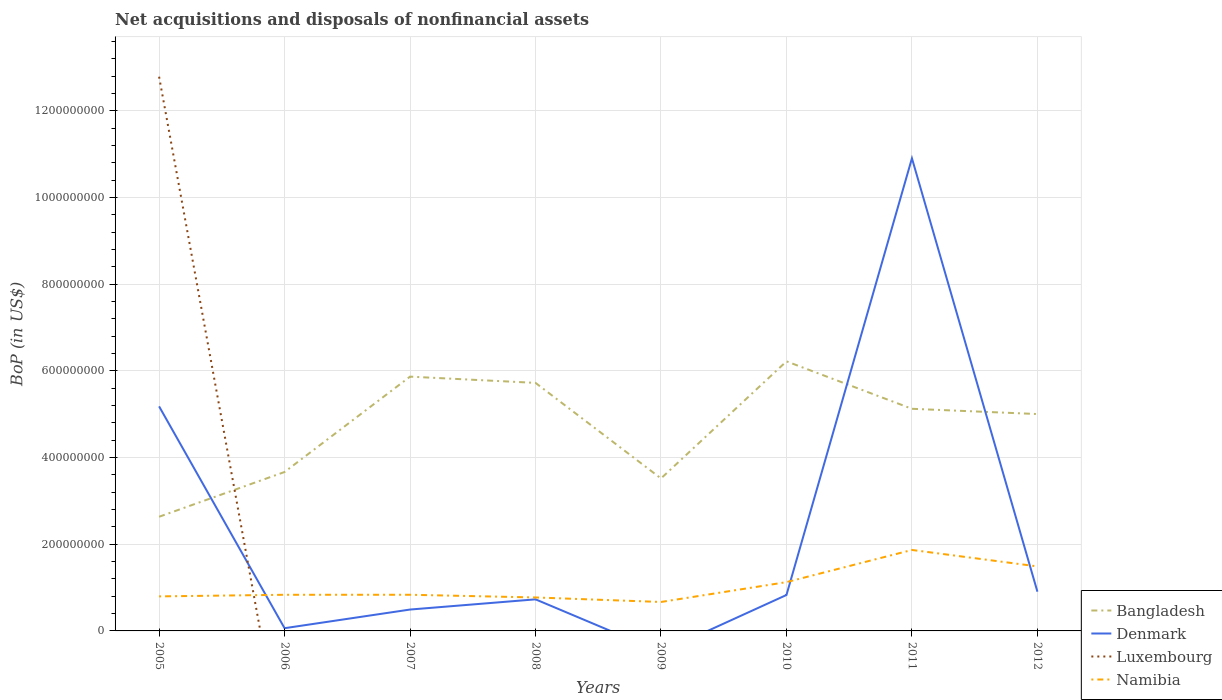Across all years, what is the maximum Balance of Payments in Denmark?
Your answer should be very brief. 0. What is the total Balance of Payments in Namibia in the graph?
Offer a very short reply. -1.10e+08. What is the difference between the highest and the second highest Balance of Payments in Bangladesh?
Your answer should be compact. 3.59e+08. How many lines are there?
Your answer should be compact. 4. How many years are there in the graph?
Your response must be concise. 8. What is the difference between two consecutive major ticks on the Y-axis?
Keep it short and to the point. 2.00e+08. Does the graph contain any zero values?
Your response must be concise. Yes. What is the title of the graph?
Make the answer very short. Net acquisitions and disposals of nonfinancial assets. What is the label or title of the X-axis?
Offer a terse response. Years. What is the label or title of the Y-axis?
Ensure brevity in your answer.  BoP (in US$). What is the BoP (in US$) of Bangladesh in 2005?
Your answer should be compact. 2.63e+08. What is the BoP (in US$) in Denmark in 2005?
Offer a very short reply. 5.18e+08. What is the BoP (in US$) of Luxembourg in 2005?
Make the answer very short. 1.28e+09. What is the BoP (in US$) of Namibia in 2005?
Keep it short and to the point. 7.97e+07. What is the BoP (in US$) in Bangladesh in 2006?
Offer a terse response. 3.67e+08. What is the BoP (in US$) in Denmark in 2006?
Provide a short and direct response. 6.28e+06. What is the BoP (in US$) in Namibia in 2006?
Ensure brevity in your answer.  8.34e+07. What is the BoP (in US$) in Bangladesh in 2007?
Make the answer very short. 5.87e+08. What is the BoP (in US$) in Denmark in 2007?
Your answer should be compact. 4.93e+07. What is the BoP (in US$) of Namibia in 2007?
Your answer should be compact. 8.34e+07. What is the BoP (in US$) of Bangladesh in 2008?
Make the answer very short. 5.72e+08. What is the BoP (in US$) in Denmark in 2008?
Ensure brevity in your answer.  7.29e+07. What is the BoP (in US$) of Luxembourg in 2008?
Ensure brevity in your answer.  0. What is the BoP (in US$) in Namibia in 2008?
Provide a succinct answer. 7.72e+07. What is the BoP (in US$) of Bangladesh in 2009?
Make the answer very short. 3.52e+08. What is the BoP (in US$) in Denmark in 2009?
Offer a very short reply. 0. What is the BoP (in US$) of Namibia in 2009?
Make the answer very short. 6.68e+07. What is the BoP (in US$) of Bangladesh in 2010?
Keep it short and to the point. 6.22e+08. What is the BoP (in US$) of Denmark in 2010?
Your response must be concise. 8.29e+07. What is the BoP (in US$) in Luxembourg in 2010?
Keep it short and to the point. 0. What is the BoP (in US$) of Namibia in 2010?
Offer a very short reply. 1.13e+08. What is the BoP (in US$) of Bangladesh in 2011?
Provide a succinct answer. 5.12e+08. What is the BoP (in US$) in Denmark in 2011?
Your answer should be very brief. 1.09e+09. What is the BoP (in US$) of Namibia in 2011?
Make the answer very short. 1.87e+08. What is the BoP (in US$) of Bangladesh in 2012?
Keep it short and to the point. 5.00e+08. What is the BoP (in US$) of Denmark in 2012?
Your response must be concise. 9.05e+07. What is the BoP (in US$) of Namibia in 2012?
Your response must be concise. 1.49e+08. Across all years, what is the maximum BoP (in US$) in Bangladesh?
Provide a succinct answer. 6.22e+08. Across all years, what is the maximum BoP (in US$) of Denmark?
Your answer should be very brief. 1.09e+09. Across all years, what is the maximum BoP (in US$) in Luxembourg?
Offer a terse response. 1.28e+09. Across all years, what is the maximum BoP (in US$) of Namibia?
Your answer should be compact. 1.87e+08. Across all years, what is the minimum BoP (in US$) of Bangladesh?
Ensure brevity in your answer.  2.63e+08. Across all years, what is the minimum BoP (in US$) of Denmark?
Your answer should be compact. 0. Across all years, what is the minimum BoP (in US$) of Luxembourg?
Ensure brevity in your answer.  0. Across all years, what is the minimum BoP (in US$) in Namibia?
Your answer should be compact. 6.68e+07. What is the total BoP (in US$) in Bangladesh in the graph?
Your answer should be compact. 3.77e+09. What is the total BoP (in US$) of Denmark in the graph?
Offer a very short reply. 1.91e+09. What is the total BoP (in US$) of Luxembourg in the graph?
Offer a very short reply. 1.28e+09. What is the total BoP (in US$) in Namibia in the graph?
Keep it short and to the point. 8.39e+08. What is the difference between the BoP (in US$) of Bangladesh in 2005 and that in 2006?
Ensure brevity in your answer.  -1.03e+08. What is the difference between the BoP (in US$) of Denmark in 2005 and that in 2006?
Your answer should be compact. 5.12e+08. What is the difference between the BoP (in US$) in Namibia in 2005 and that in 2006?
Provide a succinct answer. -3.73e+06. What is the difference between the BoP (in US$) in Bangladesh in 2005 and that in 2007?
Your response must be concise. -3.23e+08. What is the difference between the BoP (in US$) in Denmark in 2005 and that in 2007?
Offer a very short reply. 4.69e+08. What is the difference between the BoP (in US$) of Namibia in 2005 and that in 2007?
Your response must be concise. -3.75e+06. What is the difference between the BoP (in US$) of Bangladesh in 2005 and that in 2008?
Ensure brevity in your answer.  -3.09e+08. What is the difference between the BoP (in US$) of Denmark in 2005 and that in 2008?
Ensure brevity in your answer.  4.45e+08. What is the difference between the BoP (in US$) in Namibia in 2005 and that in 2008?
Keep it short and to the point. 2.45e+06. What is the difference between the BoP (in US$) in Bangladesh in 2005 and that in 2009?
Give a very brief answer. -8.84e+07. What is the difference between the BoP (in US$) of Namibia in 2005 and that in 2009?
Provide a succinct answer. 1.29e+07. What is the difference between the BoP (in US$) in Bangladesh in 2005 and that in 2010?
Provide a succinct answer. -3.59e+08. What is the difference between the BoP (in US$) in Denmark in 2005 and that in 2010?
Keep it short and to the point. 4.35e+08. What is the difference between the BoP (in US$) of Namibia in 2005 and that in 2010?
Offer a terse response. -3.29e+07. What is the difference between the BoP (in US$) of Bangladesh in 2005 and that in 2011?
Your response must be concise. -2.49e+08. What is the difference between the BoP (in US$) of Denmark in 2005 and that in 2011?
Provide a succinct answer. -5.72e+08. What is the difference between the BoP (in US$) of Namibia in 2005 and that in 2011?
Offer a terse response. -1.07e+08. What is the difference between the BoP (in US$) of Bangladesh in 2005 and that in 2012?
Make the answer very short. -2.37e+08. What is the difference between the BoP (in US$) in Denmark in 2005 and that in 2012?
Provide a short and direct response. 4.27e+08. What is the difference between the BoP (in US$) of Namibia in 2005 and that in 2012?
Provide a short and direct response. -6.92e+07. What is the difference between the BoP (in US$) in Bangladesh in 2006 and that in 2007?
Your answer should be very brief. -2.20e+08. What is the difference between the BoP (in US$) of Denmark in 2006 and that in 2007?
Your answer should be compact. -4.30e+07. What is the difference between the BoP (in US$) of Namibia in 2006 and that in 2007?
Your response must be concise. -2.69e+04. What is the difference between the BoP (in US$) of Bangladesh in 2006 and that in 2008?
Offer a very short reply. -2.06e+08. What is the difference between the BoP (in US$) of Denmark in 2006 and that in 2008?
Ensure brevity in your answer.  -6.66e+07. What is the difference between the BoP (in US$) in Namibia in 2006 and that in 2008?
Your answer should be very brief. 6.18e+06. What is the difference between the BoP (in US$) of Bangladesh in 2006 and that in 2009?
Give a very brief answer. 1.48e+07. What is the difference between the BoP (in US$) of Namibia in 2006 and that in 2009?
Offer a terse response. 1.66e+07. What is the difference between the BoP (in US$) of Bangladesh in 2006 and that in 2010?
Give a very brief answer. -2.55e+08. What is the difference between the BoP (in US$) of Denmark in 2006 and that in 2010?
Offer a very short reply. -7.66e+07. What is the difference between the BoP (in US$) of Namibia in 2006 and that in 2010?
Keep it short and to the point. -2.92e+07. What is the difference between the BoP (in US$) in Bangladesh in 2006 and that in 2011?
Make the answer very short. -1.46e+08. What is the difference between the BoP (in US$) in Denmark in 2006 and that in 2011?
Keep it short and to the point. -1.08e+09. What is the difference between the BoP (in US$) in Namibia in 2006 and that in 2011?
Offer a terse response. -1.03e+08. What is the difference between the BoP (in US$) in Bangladesh in 2006 and that in 2012?
Provide a succinct answer. -1.34e+08. What is the difference between the BoP (in US$) in Denmark in 2006 and that in 2012?
Keep it short and to the point. -8.43e+07. What is the difference between the BoP (in US$) in Namibia in 2006 and that in 2012?
Offer a terse response. -6.54e+07. What is the difference between the BoP (in US$) of Bangladesh in 2007 and that in 2008?
Give a very brief answer. 1.44e+07. What is the difference between the BoP (in US$) in Denmark in 2007 and that in 2008?
Ensure brevity in your answer.  -2.35e+07. What is the difference between the BoP (in US$) in Namibia in 2007 and that in 2008?
Offer a very short reply. 6.20e+06. What is the difference between the BoP (in US$) in Bangladesh in 2007 and that in 2009?
Provide a succinct answer. 2.35e+08. What is the difference between the BoP (in US$) of Namibia in 2007 and that in 2009?
Ensure brevity in your answer.  1.66e+07. What is the difference between the BoP (in US$) in Bangladesh in 2007 and that in 2010?
Your answer should be compact. -3.53e+07. What is the difference between the BoP (in US$) in Denmark in 2007 and that in 2010?
Ensure brevity in your answer.  -3.36e+07. What is the difference between the BoP (in US$) of Namibia in 2007 and that in 2010?
Keep it short and to the point. -2.92e+07. What is the difference between the BoP (in US$) in Bangladesh in 2007 and that in 2011?
Ensure brevity in your answer.  7.41e+07. What is the difference between the BoP (in US$) of Denmark in 2007 and that in 2011?
Your answer should be compact. -1.04e+09. What is the difference between the BoP (in US$) in Namibia in 2007 and that in 2011?
Keep it short and to the point. -1.03e+08. What is the difference between the BoP (in US$) in Bangladesh in 2007 and that in 2012?
Your answer should be compact. 8.63e+07. What is the difference between the BoP (in US$) of Denmark in 2007 and that in 2012?
Your response must be concise. -4.12e+07. What is the difference between the BoP (in US$) in Namibia in 2007 and that in 2012?
Your response must be concise. -6.54e+07. What is the difference between the BoP (in US$) of Bangladesh in 2008 and that in 2009?
Provide a succinct answer. 2.20e+08. What is the difference between the BoP (in US$) in Namibia in 2008 and that in 2009?
Provide a short and direct response. 1.04e+07. What is the difference between the BoP (in US$) in Bangladesh in 2008 and that in 2010?
Keep it short and to the point. -4.97e+07. What is the difference between the BoP (in US$) in Denmark in 2008 and that in 2010?
Your answer should be compact. -1.00e+07. What is the difference between the BoP (in US$) of Namibia in 2008 and that in 2010?
Provide a succinct answer. -3.54e+07. What is the difference between the BoP (in US$) in Bangladesh in 2008 and that in 2011?
Give a very brief answer. 5.98e+07. What is the difference between the BoP (in US$) of Denmark in 2008 and that in 2011?
Ensure brevity in your answer.  -1.02e+09. What is the difference between the BoP (in US$) in Namibia in 2008 and that in 2011?
Offer a very short reply. -1.10e+08. What is the difference between the BoP (in US$) of Bangladesh in 2008 and that in 2012?
Ensure brevity in your answer.  7.19e+07. What is the difference between the BoP (in US$) in Denmark in 2008 and that in 2012?
Provide a short and direct response. -1.77e+07. What is the difference between the BoP (in US$) in Namibia in 2008 and that in 2012?
Offer a terse response. -7.16e+07. What is the difference between the BoP (in US$) of Bangladesh in 2009 and that in 2010?
Give a very brief answer. -2.70e+08. What is the difference between the BoP (in US$) in Namibia in 2009 and that in 2010?
Offer a terse response. -4.58e+07. What is the difference between the BoP (in US$) of Bangladesh in 2009 and that in 2011?
Give a very brief answer. -1.61e+08. What is the difference between the BoP (in US$) of Namibia in 2009 and that in 2011?
Ensure brevity in your answer.  -1.20e+08. What is the difference between the BoP (in US$) in Bangladesh in 2009 and that in 2012?
Make the answer very short. -1.48e+08. What is the difference between the BoP (in US$) of Namibia in 2009 and that in 2012?
Make the answer very short. -8.21e+07. What is the difference between the BoP (in US$) of Bangladesh in 2010 and that in 2011?
Your response must be concise. 1.09e+08. What is the difference between the BoP (in US$) in Denmark in 2010 and that in 2011?
Offer a terse response. -1.01e+09. What is the difference between the BoP (in US$) of Namibia in 2010 and that in 2011?
Your response must be concise. -7.42e+07. What is the difference between the BoP (in US$) of Bangladesh in 2010 and that in 2012?
Provide a short and direct response. 1.22e+08. What is the difference between the BoP (in US$) of Denmark in 2010 and that in 2012?
Offer a very short reply. -7.67e+06. What is the difference between the BoP (in US$) of Namibia in 2010 and that in 2012?
Your answer should be very brief. -3.63e+07. What is the difference between the BoP (in US$) of Bangladesh in 2011 and that in 2012?
Offer a very short reply. 1.21e+07. What is the difference between the BoP (in US$) in Denmark in 2011 and that in 2012?
Ensure brevity in your answer.  1.00e+09. What is the difference between the BoP (in US$) of Namibia in 2011 and that in 2012?
Offer a very short reply. 3.79e+07. What is the difference between the BoP (in US$) of Bangladesh in 2005 and the BoP (in US$) of Denmark in 2006?
Give a very brief answer. 2.57e+08. What is the difference between the BoP (in US$) in Bangladesh in 2005 and the BoP (in US$) in Namibia in 2006?
Offer a terse response. 1.80e+08. What is the difference between the BoP (in US$) in Denmark in 2005 and the BoP (in US$) in Namibia in 2006?
Offer a terse response. 4.35e+08. What is the difference between the BoP (in US$) in Luxembourg in 2005 and the BoP (in US$) in Namibia in 2006?
Your answer should be very brief. 1.20e+09. What is the difference between the BoP (in US$) in Bangladesh in 2005 and the BoP (in US$) in Denmark in 2007?
Your answer should be compact. 2.14e+08. What is the difference between the BoP (in US$) in Bangladesh in 2005 and the BoP (in US$) in Namibia in 2007?
Your response must be concise. 1.80e+08. What is the difference between the BoP (in US$) in Denmark in 2005 and the BoP (in US$) in Namibia in 2007?
Your answer should be very brief. 4.35e+08. What is the difference between the BoP (in US$) of Luxembourg in 2005 and the BoP (in US$) of Namibia in 2007?
Your answer should be very brief. 1.20e+09. What is the difference between the BoP (in US$) of Bangladesh in 2005 and the BoP (in US$) of Denmark in 2008?
Your response must be concise. 1.90e+08. What is the difference between the BoP (in US$) in Bangladesh in 2005 and the BoP (in US$) in Namibia in 2008?
Keep it short and to the point. 1.86e+08. What is the difference between the BoP (in US$) of Denmark in 2005 and the BoP (in US$) of Namibia in 2008?
Provide a short and direct response. 4.41e+08. What is the difference between the BoP (in US$) in Luxembourg in 2005 and the BoP (in US$) in Namibia in 2008?
Give a very brief answer. 1.20e+09. What is the difference between the BoP (in US$) in Bangladesh in 2005 and the BoP (in US$) in Namibia in 2009?
Offer a terse response. 1.97e+08. What is the difference between the BoP (in US$) of Denmark in 2005 and the BoP (in US$) of Namibia in 2009?
Your answer should be compact. 4.51e+08. What is the difference between the BoP (in US$) of Luxembourg in 2005 and the BoP (in US$) of Namibia in 2009?
Offer a terse response. 1.21e+09. What is the difference between the BoP (in US$) in Bangladesh in 2005 and the BoP (in US$) in Denmark in 2010?
Your answer should be compact. 1.80e+08. What is the difference between the BoP (in US$) in Bangladesh in 2005 and the BoP (in US$) in Namibia in 2010?
Give a very brief answer. 1.51e+08. What is the difference between the BoP (in US$) of Denmark in 2005 and the BoP (in US$) of Namibia in 2010?
Make the answer very short. 4.05e+08. What is the difference between the BoP (in US$) in Luxembourg in 2005 and the BoP (in US$) in Namibia in 2010?
Make the answer very short. 1.17e+09. What is the difference between the BoP (in US$) in Bangladesh in 2005 and the BoP (in US$) in Denmark in 2011?
Make the answer very short. -8.27e+08. What is the difference between the BoP (in US$) of Bangladesh in 2005 and the BoP (in US$) of Namibia in 2011?
Offer a very short reply. 7.66e+07. What is the difference between the BoP (in US$) of Denmark in 2005 and the BoP (in US$) of Namibia in 2011?
Your answer should be very brief. 3.31e+08. What is the difference between the BoP (in US$) in Luxembourg in 2005 and the BoP (in US$) in Namibia in 2011?
Your response must be concise. 1.09e+09. What is the difference between the BoP (in US$) in Bangladesh in 2005 and the BoP (in US$) in Denmark in 2012?
Offer a very short reply. 1.73e+08. What is the difference between the BoP (in US$) in Bangladesh in 2005 and the BoP (in US$) in Namibia in 2012?
Your answer should be very brief. 1.15e+08. What is the difference between the BoP (in US$) of Denmark in 2005 and the BoP (in US$) of Namibia in 2012?
Provide a succinct answer. 3.69e+08. What is the difference between the BoP (in US$) of Luxembourg in 2005 and the BoP (in US$) of Namibia in 2012?
Your answer should be compact. 1.13e+09. What is the difference between the BoP (in US$) of Bangladesh in 2006 and the BoP (in US$) of Denmark in 2007?
Provide a short and direct response. 3.17e+08. What is the difference between the BoP (in US$) in Bangladesh in 2006 and the BoP (in US$) in Namibia in 2007?
Offer a terse response. 2.83e+08. What is the difference between the BoP (in US$) in Denmark in 2006 and the BoP (in US$) in Namibia in 2007?
Give a very brief answer. -7.71e+07. What is the difference between the BoP (in US$) of Bangladesh in 2006 and the BoP (in US$) of Denmark in 2008?
Provide a succinct answer. 2.94e+08. What is the difference between the BoP (in US$) of Bangladesh in 2006 and the BoP (in US$) of Namibia in 2008?
Your response must be concise. 2.89e+08. What is the difference between the BoP (in US$) in Denmark in 2006 and the BoP (in US$) in Namibia in 2008?
Keep it short and to the point. -7.09e+07. What is the difference between the BoP (in US$) in Bangladesh in 2006 and the BoP (in US$) in Namibia in 2009?
Your answer should be compact. 3.00e+08. What is the difference between the BoP (in US$) in Denmark in 2006 and the BoP (in US$) in Namibia in 2009?
Ensure brevity in your answer.  -6.05e+07. What is the difference between the BoP (in US$) in Bangladesh in 2006 and the BoP (in US$) in Denmark in 2010?
Provide a short and direct response. 2.84e+08. What is the difference between the BoP (in US$) in Bangladesh in 2006 and the BoP (in US$) in Namibia in 2010?
Keep it short and to the point. 2.54e+08. What is the difference between the BoP (in US$) of Denmark in 2006 and the BoP (in US$) of Namibia in 2010?
Your answer should be very brief. -1.06e+08. What is the difference between the BoP (in US$) of Bangladesh in 2006 and the BoP (in US$) of Denmark in 2011?
Ensure brevity in your answer.  -7.24e+08. What is the difference between the BoP (in US$) of Bangladesh in 2006 and the BoP (in US$) of Namibia in 2011?
Keep it short and to the point. 1.80e+08. What is the difference between the BoP (in US$) of Denmark in 2006 and the BoP (in US$) of Namibia in 2011?
Give a very brief answer. -1.80e+08. What is the difference between the BoP (in US$) of Bangladesh in 2006 and the BoP (in US$) of Denmark in 2012?
Your answer should be compact. 2.76e+08. What is the difference between the BoP (in US$) in Bangladesh in 2006 and the BoP (in US$) in Namibia in 2012?
Provide a succinct answer. 2.18e+08. What is the difference between the BoP (in US$) in Denmark in 2006 and the BoP (in US$) in Namibia in 2012?
Your response must be concise. -1.43e+08. What is the difference between the BoP (in US$) of Bangladesh in 2007 and the BoP (in US$) of Denmark in 2008?
Offer a very short reply. 5.14e+08. What is the difference between the BoP (in US$) of Bangladesh in 2007 and the BoP (in US$) of Namibia in 2008?
Provide a short and direct response. 5.09e+08. What is the difference between the BoP (in US$) in Denmark in 2007 and the BoP (in US$) in Namibia in 2008?
Ensure brevity in your answer.  -2.79e+07. What is the difference between the BoP (in US$) of Bangladesh in 2007 and the BoP (in US$) of Namibia in 2009?
Your response must be concise. 5.20e+08. What is the difference between the BoP (in US$) of Denmark in 2007 and the BoP (in US$) of Namibia in 2009?
Make the answer very short. -1.75e+07. What is the difference between the BoP (in US$) of Bangladesh in 2007 and the BoP (in US$) of Denmark in 2010?
Ensure brevity in your answer.  5.04e+08. What is the difference between the BoP (in US$) in Bangladesh in 2007 and the BoP (in US$) in Namibia in 2010?
Your answer should be compact. 4.74e+08. What is the difference between the BoP (in US$) in Denmark in 2007 and the BoP (in US$) in Namibia in 2010?
Ensure brevity in your answer.  -6.33e+07. What is the difference between the BoP (in US$) of Bangladesh in 2007 and the BoP (in US$) of Denmark in 2011?
Your answer should be compact. -5.04e+08. What is the difference between the BoP (in US$) in Bangladesh in 2007 and the BoP (in US$) in Namibia in 2011?
Offer a terse response. 4.00e+08. What is the difference between the BoP (in US$) of Denmark in 2007 and the BoP (in US$) of Namibia in 2011?
Make the answer very short. -1.37e+08. What is the difference between the BoP (in US$) of Bangladesh in 2007 and the BoP (in US$) of Denmark in 2012?
Your response must be concise. 4.96e+08. What is the difference between the BoP (in US$) in Bangladesh in 2007 and the BoP (in US$) in Namibia in 2012?
Make the answer very short. 4.38e+08. What is the difference between the BoP (in US$) in Denmark in 2007 and the BoP (in US$) in Namibia in 2012?
Your answer should be compact. -9.95e+07. What is the difference between the BoP (in US$) in Bangladesh in 2008 and the BoP (in US$) in Namibia in 2009?
Provide a succinct answer. 5.05e+08. What is the difference between the BoP (in US$) of Denmark in 2008 and the BoP (in US$) of Namibia in 2009?
Offer a terse response. 6.08e+06. What is the difference between the BoP (in US$) in Bangladesh in 2008 and the BoP (in US$) in Denmark in 2010?
Give a very brief answer. 4.89e+08. What is the difference between the BoP (in US$) of Bangladesh in 2008 and the BoP (in US$) of Namibia in 2010?
Give a very brief answer. 4.60e+08. What is the difference between the BoP (in US$) in Denmark in 2008 and the BoP (in US$) in Namibia in 2010?
Make the answer very short. -3.97e+07. What is the difference between the BoP (in US$) of Bangladesh in 2008 and the BoP (in US$) of Denmark in 2011?
Your answer should be very brief. -5.18e+08. What is the difference between the BoP (in US$) of Bangladesh in 2008 and the BoP (in US$) of Namibia in 2011?
Offer a terse response. 3.85e+08. What is the difference between the BoP (in US$) in Denmark in 2008 and the BoP (in US$) in Namibia in 2011?
Provide a succinct answer. -1.14e+08. What is the difference between the BoP (in US$) of Bangladesh in 2008 and the BoP (in US$) of Denmark in 2012?
Your answer should be compact. 4.82e+08. What is the difference between the BoP (in US$) of Bangladesh in 2008 and the BoP (in US$) of Namibia in 2012?
Your response must be concise. 4.23e+08. What is the difference between the BoP (in US$) of Denmark in 2008 and the BoP (in US$) of Namibia in 2012?
Ensure brevity in your answer.  -7.60e+07. What is the difference between the BoP (in US$) in Bangladesh in 2009 and the BoP (in US$) in Denmark in 2010?
Your answer should be compact. 2.69e+08. What is the difference between the BoP (in US$) of Bangladesh in 2009 and the BoP (in US$) of Namibia in 2010?
Your response must be concise. 2.39e+08. What is the difference between the BoP (in US$) in Bangladesh in 2009 and the BoP (in US$) in Denmark in 2011?
Make the answer very short. -7.39e+08. What is the difference between the BoP (in US$) in Bangladesh in 2009 and the BoP (in US$) in Namibia in 2011?
Ensure brevity in your answer.  1.65e+08. What is the difference between the BoP (in US$) in Bangladesh in 2009 and the BoP (in US$) in Denmark in 2012?
Ensure brevity in your answer.  2.61e+08. What is the difference between the BoP (in US$) of Bangladesh in 2009 and the BoP (in US$) of Namibia in 2012?
Keep it short and to the point. 2.03e+08. What is the difference between the BoP (in US$) of Bangladesh in 2010 and the BoP (in US$) of Denmark in 2011?
Your answer should be very brief. -4.68e+08. What is the difference between the BoP (in US$) in Bangladesh in 2010 and the BoP (in US$) in Namibia in 2011?
Your answer should be very brief. 4.35e+08. What is the difference between the BoP (in US$) of Denmark in 2010 and the BoP (in US$) of Namibia in 2011?
Provide a succinct answer. -1.04e+08. What is the difference between the BoP (in US$) in Bangladesh in 2010 and the BoP (in US$) in Denmark in 2012?
Make the answer very short. 5.31e+08. What is the difference between the BoP (in US$) in Bangladesh in 2010 and the BoP (in US$) in Namibia in 2012?
Keep it short and to the point. 4.73e+08. What is the difference between the BoP (in US$) of Denmark in 2010 and the BoP (in US$) of Namibia in 2012?
Give a very brief answer. -6.60e+07. What is the difference between the BoP (in US$) of Bangladesh in 2011 and the BoP (in US$) of Denmark in 2012?
Your answer should be very brief. 4.22e+08. What is the difference between the BoP (in US$) in Bangladesh in 2011 and the BoP (in US$) in Namibia in 2012?
Offer a very short reply. 3.64e+08. What is the difference between the BoP (in US$) of Denmark in 2011 and the BoP (in US$) of Namibia in 2012?
Your answer should be very brief. 9.41e+08. What is the average BoP (in US$) in Bangladesh per year?
Offer a terse response. 4.72e+08. What is the average BoP (in US$) in Denmark per year?
Provide a succinct answer. 2.39e+08. What is the average BoP (in US$) of Luxembourg per year?
Your answer should be compact. 1.60e+08. What is the average BoP (in US$) of Namibia per year?
Ensure brevity in your answer.  1.05e+08. In the year 2005, what is the difference between the BoP (in US$) of Bangladesh and BoP (in US$) of Denmark?
Offer a terse response. -2.55e+08. In the year 2005, what is the difference between the BoP (in US$) of Bangladesh and BoP (in US$) of Luxembourg?
Offer a terse response. -1.02e+09. In the year 2005, what is the difference between the BoP (in US$) of Bangladesh and BoP (in US$) of Namibia?
Provide a succinct answer. 1.84e+08. In the year 2005, what is the difference between the BoP (in US$) in Denmark and BoP (in US$) in Luxembourg?
Offer a very short reply. -7.60e+08. In the year 2005, what is the difference between the BoP (in US$) in Denmark and BoP (in US$) in Namibia?
Your answer should be compact. 4.38e+08. In the year 2005, what is the difference between the BoP (in US$) in Luxembourg and BoP (in US$) in Namibia?
Provide a short and direct response. 1.20e+09. In the year 2006, what is the difference between the BoP (in US$) in Bangladesh and BoP (in US$) in Denmark?
Keep it short and to the point. 3.60e+08. In the year 2006, what is the difference between the BoP (in US$) of Bangladesh and BoP (in US$) of Namibia?
Give a very brief answer. 2.83e+08. In the year 2006, what is the difference between the BoP (in US$) of Denmark and BoP (in US$) of Namibia?
Ensure brevity in your answer.  -7.71e+07. In the year 2007, what is the difference between the BoP (in US$) of Bangladesh and BoP (in US$) of Denmark?
Offer a terse response. 5.37e+08. In the year 2007, what is the difference between the BoP (in US$) of Bangladesh and BoP (in US$) of Namibia?
Your answer should be very brief. 5.03e+08. In the year 2007, what is the difference between the BoP (in US$) of Denmark and BoP (in US$) of Namibia?
Provide a short and direct response. -3.41e+07. In the year 2008, what is the difference between the BoP (in US$) in Bangladesh and BoP (in US$) in Denmark?
Your answer should be very brief. 4.99e+08. In the year 2008, what is the difference between the BoP (in US$) in Bangladesh and BoP (in US$) in Namibia?
Keep it short and to the point. 4.95e+08. In the year 2008, what is the difference between the BoP (in US$) in Denmark and BoP (in US$) in Namibia?
Provide a succinct answer. -4.35e+06. In the year 2009, what is the difference between the BoP (in US$) of Bangladesh and BoP (in US$) of Namibia?
Your answer should be very brief. 2.85e+08. In the year 2010, what is the difference between the BoP (in US$) in Bangladesh and BoP (in US$) in Denmark?
Your answer should be compact. 5.39e+08. In the year 2010, what is the difference between the BoP (in US$) in Bangladesh and BoP (in US$) in Namibia?
Your answer should be very brief. 5.09e+08. In the year 2010, what is the difference between the BoP (in US$) of Denmark and BoP (in US$) of Namibia?
Your answer should be compact. -2.97e+07. In the year 2011, what is the difference between the BoP (in US$) in Bangladesh and BoP (in US$) in Denmark?
Provide a succinct answer. -5.78e+08. In the year 2011, what is the difference between the BoP (in US$) of Bangladesh and BoP (in US$) of Namibia?
Keep it short and to the point. 3.26e+08. In the year 2011, what is the difference between the BoP (in US$) of Denmark and BoP (in US$) of Namibia?
Provide a succinct answer. 9.04e+08. In the year 2012, what is the difference between the BoP (in US$) in Bangladesh and BoP (in US$) in Denmark?
Provide a short and direct response. 4.10e+08. In the year 2012, what is the difference between the BoP (in US$) in Bangladesh and BoP (in US$) in Namibia?
Your response must be concise. 3.51e+08. In the year 2012, what is the difference between the BoP (in US$) of Denmark and BoP (in US$) of Namibia?
Your answer should be compact. -5.83e+07. What is the ratio of the BoP (in US$) of Bangladesh in 2005 to that in 2006?
Offer a very short reply. 0.72. What is the ratio of the BoP (in US$) in Denmark in 2005 to that in 2006?
Your answer should be very brief. 82.45. What is the ratio of the BoP (in US$) in Namibia in 2005 to that in 2006?
Your answer should be compact. 0.96. What is the ratio of the BoP (in US$) of Bangladesh in 2005 to that in 2007?
Offer a very short reply. 0.45. What is the ratio of the BoP (in US$) of Denmark in 2005 to that in 2007?
Ensure brevity in your answer.  10.5. What is the ratio of the BoP (in US$) in Namibia in 2005 to that in 2007?
Provide a short and direct response. 0.95. What is the ratio of the BoP (in US$) in Bangladesh in 2005 to that in 2008?
Give a very brief answer. 0.46. What is the ratio of the BoP (in US$) of Denmark in 2005 to that in 2008?
Keep it short and to the point. 7.11. What is the ratio of the BoP (in US$) of Namibia in 2005 to that in 2008?
Make the answer very short. 1.03. What is the ratio of the BoP (in US$) in Bangladesh in 2005 to that in 2009?
Your answer should be very brief. 0.75. What is the ratio of the BoP (in US$) in Namibia in 2005 to that in 2009?
Keep it short and to the point. 1.19. What is the ratio of the BoP (in US$) of Bangladesh in 2005 to that in 2010?
Your response must be concise. 0.42. What is the ratio of the BoP (in US$) of Denmark in 2005 to that in 2010?
Offer a terse response. 6.25. What is the ratio of the BoP (in US$) of Namibia in 2005 to that in 2010?
Keep it short and to the point. 0.71. What is the ratio of the BoP (in US$) in Bangladesh in 2005 to that in 2011?
Offer a terse response. 0.51. What is the ratio of the BoP (in US$) of Denmark in 2005 to that in 2011?
Your response must be concise. 0.48. What is the ratio of the BoP (in US$) in Namibia in 2005 to that in 2011?
Your answer should be compact. 0.43. What is the ratio of the BoP (in US$) in Bangladesh in 2005 to that in 2012?
Provide a short and direct response. 0.53. What is the ratio of the BoP (in US$) of Denmark in 2005 to that in 2012?
Your answer should be very brief. 5.72. What is the ratio of the BoP (in US$) in Namibia in 2005 to that in 2012?
Offer a terse response. 0.54. What is the ratio of the BoP (in US$) of Bangladesh in 2006 to that in 2007?
Ensure brevity in your answer.  0.62. What is the ratio of the BoP (in US$) in Denmark in 2006 to that in 2007?
Your answer should be compact. 0.13. What is the ratio of the BoP (in US$) of Namibia in 2006 to that in 2007?
Provide a succinct answer. 1. What is the ratio of the BoP (in US$) in Bangladesh in 2006 to that in 2008?
Provide a succinct answer. 0.64. What is the ratio of the BoP (in US$) of Denmark in 2006 to that in 2008?
Offer a terse response. 0.09. What is the ratio of the BoP (in US$) of Bangladesh in 2006 to that in 2009?
Offer a terse response. 1.04. What is the ratio of the BoP (in US$) of Namibia in 2006 to that in 2009?
Give a very brief answer. 1.25. What is the ratio of the BoP (in US$) in Bangladesh in 2006 to that in 2010?
Make the answer very short. 0.59. What is the ratio of the BoP (in US$) in Denmark in 2006 to that in 2010?
Provide a short and direct response. 0.08. What is the ratio of the BoP (in US$) of Namibia in 2006 to that in 2010?
Provide a short and direct response. 0.74. What is the ratio of the BoP (in US$) in Bangladesh in 2006 to that in 2011?
Ensure brevity in your answer.  0.72. What is the ratio of the BoP (in US$) of Denmark in 2006 to that in 2011?
Offer a terse response. 0.01. What is the ratio of the BoP (in US$) of Namibia in 2006 to that in 2011?
Offer a very short reply. 0.45. What is the ratio of the BoP (in US$) in Bangladesh in 2006 to that in 2012?
Your answer should be compact. 0.73. What is the ratio of the BoP (in US$) of Denmark in 2006 to that in 2012?
Ensure brevity in your answer.  0.07. What is the ratio of the BoP (in US$) of Namibia in 2006 to that in 2012?
Your answer should be compact. 0.56. What is the ratio of the BoP (in US$) in Bangladesh in 2007 to that in 2008?
Give a very brief answer. 1.03. What is the ratio of the BoP (in US$) in Denmark in 2007 to that in 2008?
Keep it short and to the point. 0.68. What is the ratio of the BoP (in US$) of Namibia in 2007 to that in 2008?
Make the answer very short. 1.08. What is the ratio of the BoP (in US$) of Bangladesh in 2007 to that in 2009?
Offer a terse response. 1.67. What is the ratio of the BoP (in US$) of Namibia in 2007 to that in 2009?
Ensure brevity in your answer.  1.25. What is the ratio of the BoP (in US$) of Bangladesh in 2007 to that in 2010?
Offer a terse response. 0.94. What is the ratio of the BoP (in US$) of Denmark in 2007 to that in 2010?
Provide a succinct answer. 0.59. What is the ratio of the BoP (in US$) of Namibia in 2007 to that in 2010?
Provide a succinct answer. 0.74. What is the ratio of the BoP (in US$) of Bangladesh in 2007 to that in 2011?
Your answer should be very brief. 1.14. What is the ratio of the BoP (in US$) of Denmark in 2007 to that in 2011?
Make the answer very short. 0.05. What is the ratio of the BoP (in US$) in Namibia in 2007 to that in 2011?
Give a very brief answer. 0.45. What is the ratio of the BoP (in US$) in Bangladesh in 2007 to that in 2012?
Provide a succinct answer. 1.17. What is the ratio of the BoP (in US$) of Denmark in 2007 to that in 2012?
Offer a terse response. 0.54. What is the ratio of the BoP (in US$) in Namibia in 2007 to that in 2012?
Your response must be concise. 0.56. What is the ratio of the BoP (in US$) of Bangladesh in 2008 to that in 2009?
Give a very brief answer. 1.63. What is the ratio of the BoP (in US$) in Namibia in 2008 to that in 2009?
Your response must be concise. 1.16. What is the ratio of the BoP (in US$) in Bangladesh in 2008 to that in 2010?
Provide a succinct answer. 0.92. What is the ratio of the BoP (in US$) of Denmark in 2008 to that in 2010?
Offer a terse response. 0.88. What is the ratio of the BoP (in US$) in Namibia in 2008 to that in 2010?
Offer a terse response. 0.69. What is the ratio of the BoP (in US$) of Bangladesh in 2008 to that in 2011?
Provide a short and direct response. 1.12. What is the ratio of the BoP (in US$) of Denmark in 2008 to that in 2011?
Ensure brevity in your answer.  0.07. What is the ratio of the BoP (in US$) in Namibia in 2008 to that in 2011?
Provide a short and direct response. 0.41. What is the ratio of the BoP (in US$) of Bangladesh in 2008 to that in 2012?
Keep it short and to the point. 1.14. What is the ratio of the BoP (in US$) of Denmark in 2008 to that in 2012?
Your answer should be compact. 0.8. What is the ratio of the BoP (in US$) of Namibia in 2008 to that in 2012?
Provide a succinct answer. 0.52. What is the ratio of the BoP (in US$) of Bangladesh in 2009 to that in 2010?
Your response must be concise. 0.57. What is the ratio of the BoP (in US$) of Namibia in 2009 to that in 2010?
Ensure brevity in your answer.  0.59. What is the ratio of the BoP (in US$) of Bangladesh in 2009 to that in 2011?
Your response must be concise. 0.69. What is the ratio of the BoP (in US$) in Namibia in 2009 to that in 2011?
Give a very brief answer. 0.36. What is the ratio of the BoP (in US$) of Bangladesh in 2009 to that in 2012?
Make the answer very short. 0.7. What is the ratio of the BoP (in US$) of Namibia in 2009 to that in 2012?
Keep it short and to the point. 0.45. What is the ratio of the BoP (in US$) in Bangladesh in 2010 to that in 2011?
Ensure brevity in your answer.  1.21. What is the ratio of the BoP (in US$) in Denmark in 2010 to that in 2011?
Make the answer very short. 0.08. What is the ratio of the BoP (in US$) of Namibia in 2010 to that in 2011?
Provide a short and direct response. 0.6. What is the ratio of the BoP (in US$) in Bangladesh in 2010 to that in 2012?
Make the answer very short. 1.24. What is the ratio of the BoP (in US$) of Denmark in 2010 to that in 2012?
Give a very brief answer. 0.92. What is the ratio of the BoP (in US$) in Namibia in 2010 to that in 2012?
Ensure brevity in your answer.  0.76. What is the ratio of the BoP (in US$) of Bangladesh in 2011 to that in 2012?
Ensure brevity in your answer.  1.02. What is the ratio of the BoP (in US$) of Denmark in 2011 to that in 2012?
Give a very brief answer. 12.04. What is the ratio of the BoP (in US$) in Namibia in 2011 to that in 2012?
Make the answer very short. 1.25. What is the difference between the highest and the second highest BoP (in US$) of Bangladesh?
Offer a very short reply. 3.53e+07. What is the difference between the highest and the second highest BoP (in US$) of Denmark?
Your answer should be very brief. 5.72e+08. What is the difference between the highest and the second highest BoP (in US$) in Namibia?
Provide a short and direct response. 3.79e+07. What is the difference between the highest and the lowest BoP (in US$) in Bangladesh?
Provide a short and direct response. 3.59e+08. What is the difference between the highest and the lowest BoP (in US$) in Denmark?
Provide a short and direct response. 1.09e+09. What is the difference between the highest and the lowest BoP (in US$) of Luxembourg?
Offer a terse response. 1.28e+09. What is the difference between the highest and the lowest BoP (in US$) of Namibia?
Offer a very short reply. 1.20e+08. 